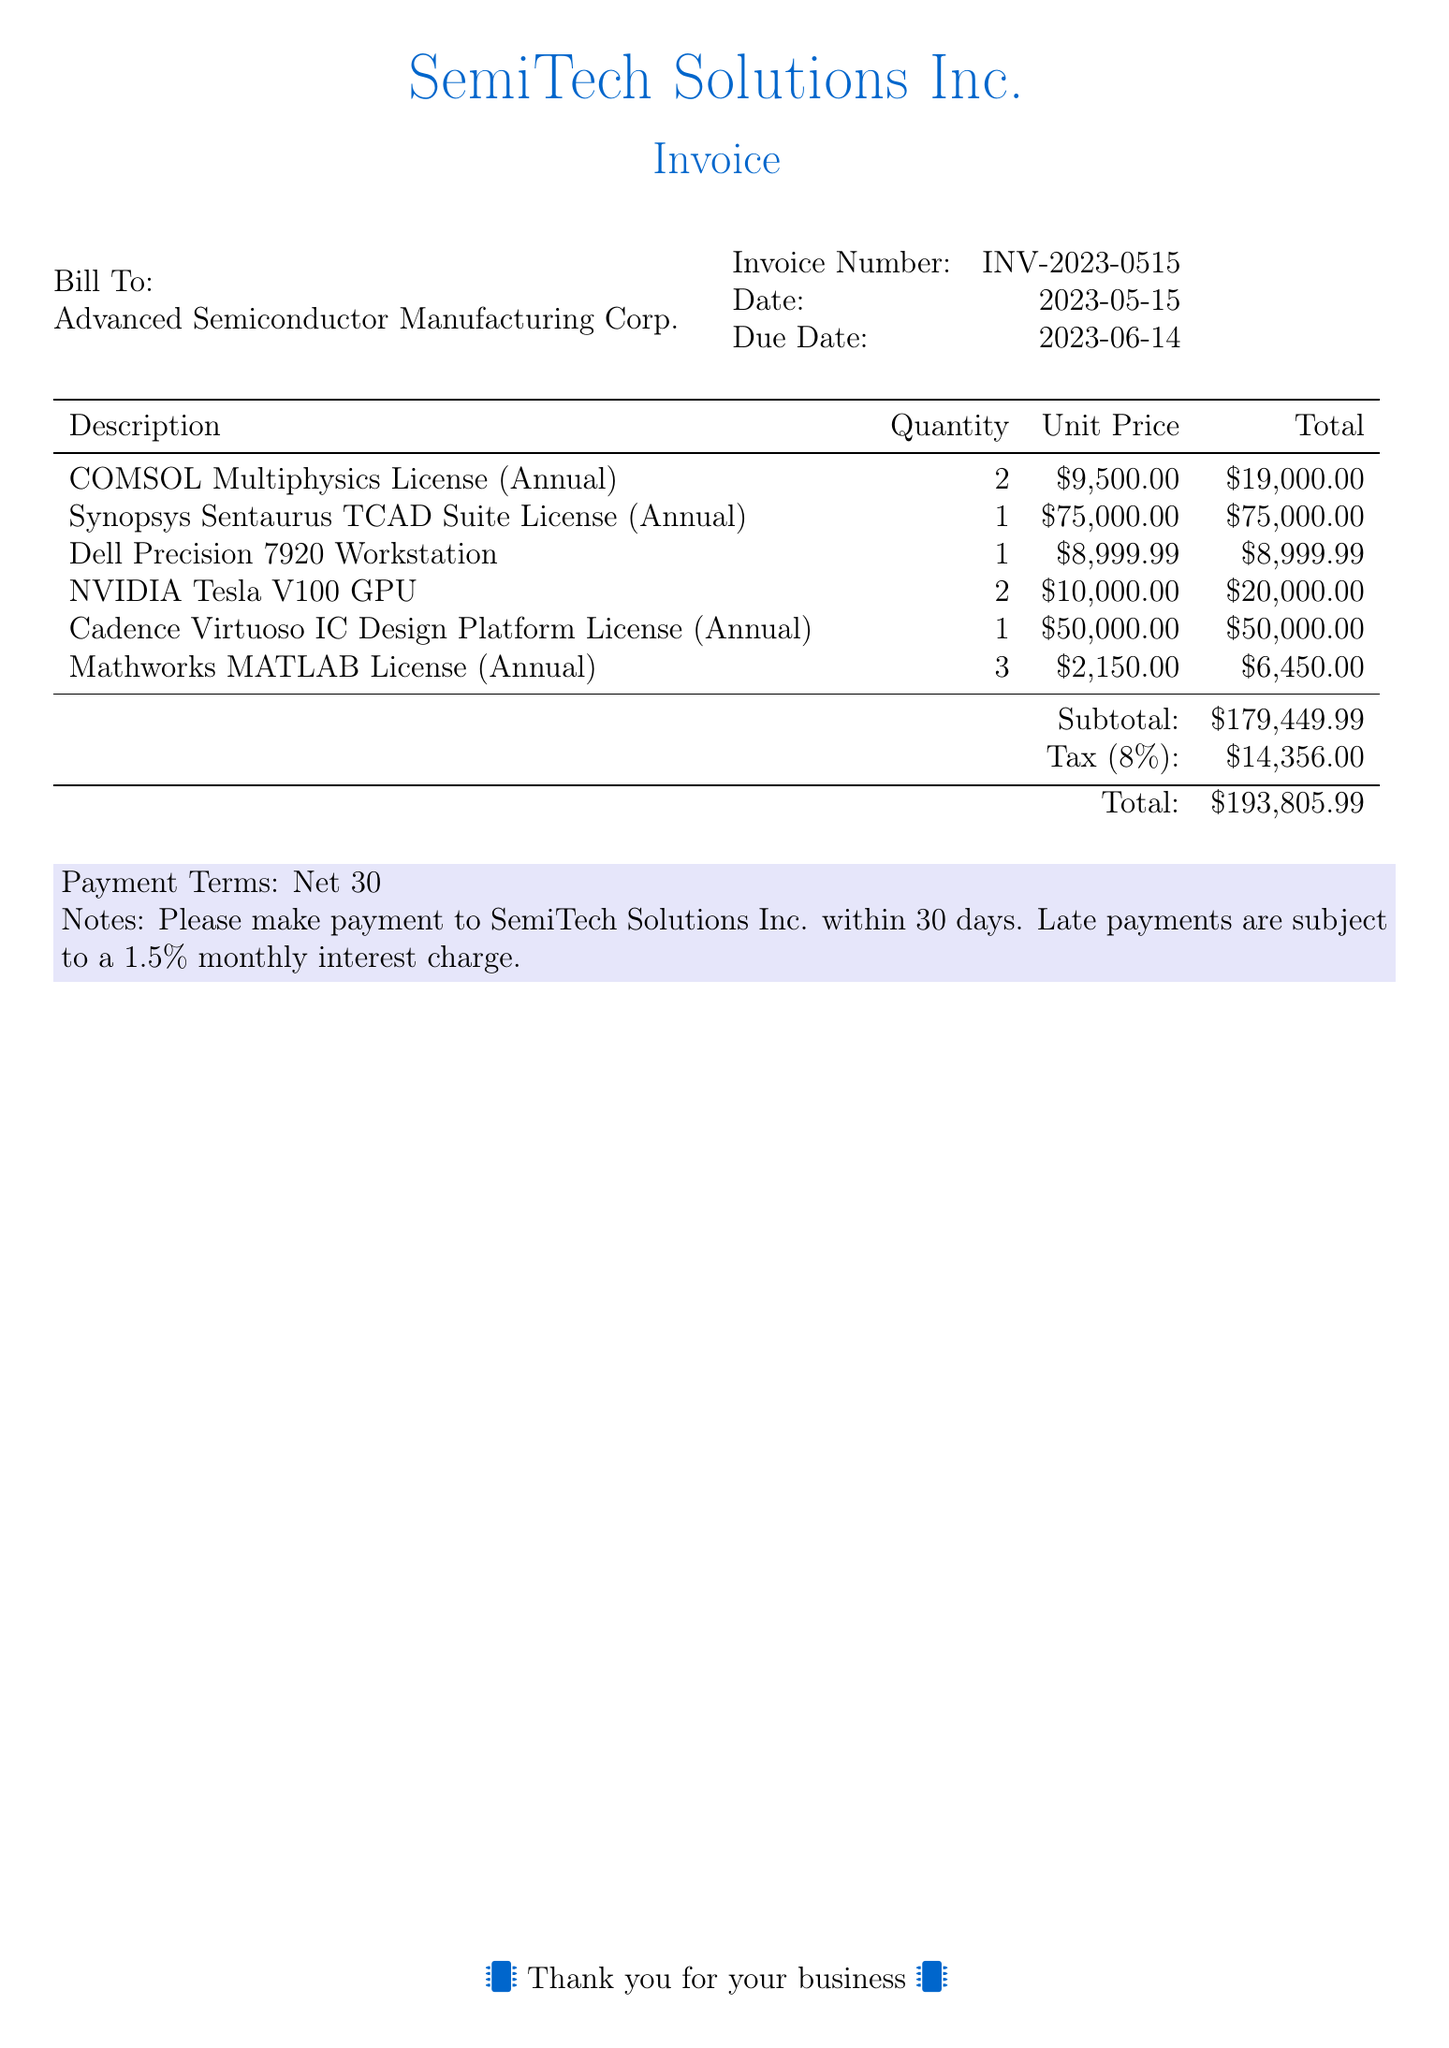What is the invoice number? The invoice number is provided in the document, which is used for identification.
Answer: INV-2023-0515 What is the due date for payment? The due date indicates when the payment should be made, as stated in the document.
Answer: 2023-06-14 How many licenses of COMSOL Multiphysics were purchased? The quantity of COMSOL Multiphysics licenses is listed in the itemized section of the bill.
Answer: 2 What is the total amount before tax? The subtotal shows the total amount before tax is calculated.
Answer: $179,449.99 What is the tax rate applied in this invoice? The tax rate is mentioned as part of the total calculations.
Answer: 8% What is the total amount due? The total shows the final amount that needs to be paid, including tax.
Answer: $193,805.99 Who is the billing recipient? The recipient's name is specified at the beginning of the document.
Answer: Advanced Semiconductor Manufacturing Corp What are the payment terms specified in the document? The payment terms are conditions under which payment should be made.
Answer: Net 30 How many different software licenses were included in the bill? The document lists each software license as a separate line item, indicating the number of different licenses.
Answer: 5 